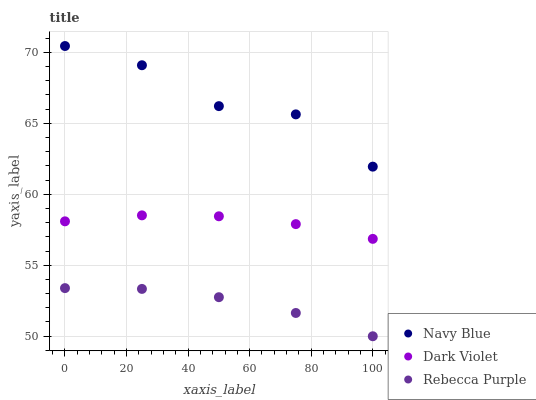Does Rebecca Purple have the minimum area under the curve?
Answer yes or no. Yes. Does Navy Blue have the maximum area under the curve?
Answer yes or no. Yes. Does Dark Violet have the minimum area under the curve?
Answer yes or no. No. Does Dark Violet have the maximum area under the curve?
Answer yes or no. No. Is Dark Violet the smoothest?
Answer yes or no. Yes. Is Navy Blue the roughest?
Answer yes or no. Yes. Is Rebecca Purple the smoothest?
Answer yes or no. No. Is Rebecca Purple the roughest?
Answer yes or no. No. Does Rebecca Purple have the lowest value?
Answer yes or no. Yes. Does Dark Violet have the lowest value?
Answer yes or no. No. Does Navy Blue have the highest value?
Answer yes or no. Yes. Does Dark Violet have the highest value?
Answer yes or no. No. Is Rebecca Purple less than Navy Blue?
Answer yes or no. Yes. Is Navy Blue greater than Rebecca Purple?
Answer yes or no. Yes. Does Rebecca Purple intersect Navy Blue?
Answer yes or no. No. 